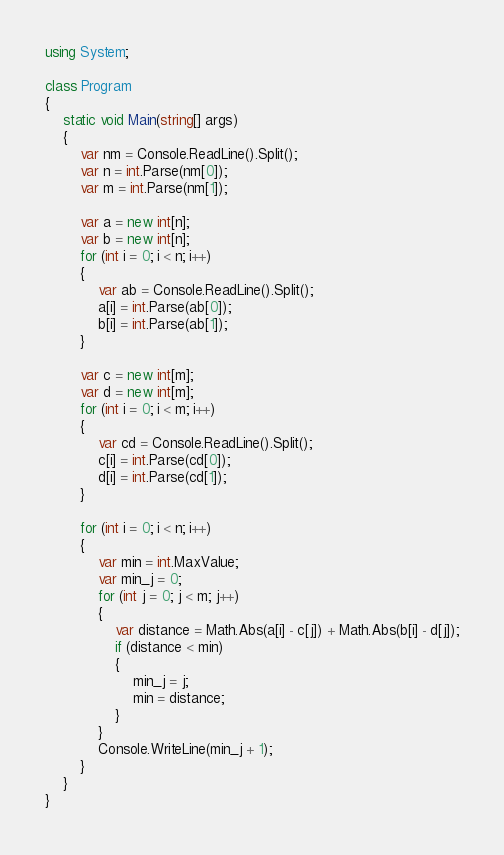Convert code to text. <code><loc_0><loc_0><loc_500><loc_500><_C#_>using System;

class Program
{
    static void Main(string[] args)
    {
        var nm = Console.ReadLine().Split();
        var n = int.Parse(nm[0]);
        var m = int.Parse(nm[1]);

        var a = new int[n];
        var b = new int[n];
        for (int i = 0; i < n; i++)
        {
            var ab = Console.ReadLine().Split();
            a[i] = int.Parse(ab[0]);
            b[i] = int.Parse(ab[1]);
        }

        var c = new int[m];
        var d = new int[m];
        for (int i = 0; i < m; i++)
        {
            var cd = Console.ReadLine().Split();
            c[i] = int.Parse(cd[0]);
            d[i] = int.Parse(cd[1]);
        }

        for (int i = 0; i < n; i++)
        {
            var min = int.MaxValue;
            var min_j = 0;
            for (int j = 0; j < m; j++)
            {
                var distance = Math.Abs(a[i] - c[j]) + Math.Abs(b[i] - d[j]);
                if (distance < min)
                {
                    min_j = j;
                    min = distance;
                }
            }
            Console.WriteLine(min_j + 1);
        }
    }
}
</code> 